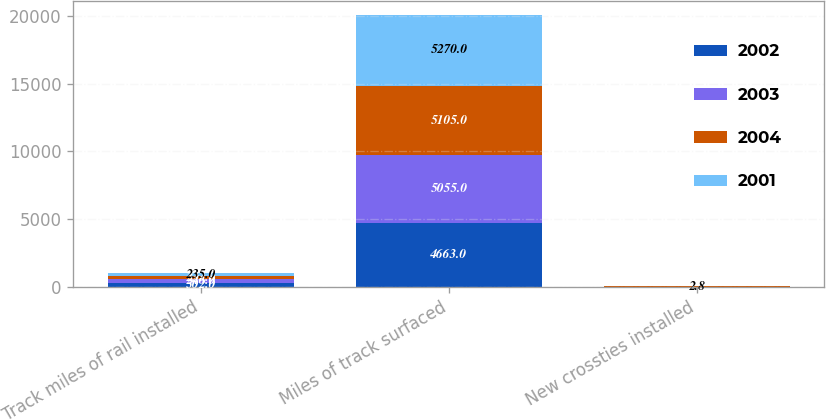Convert chart to OTSL. <chart><loc_0><loc_0><loc_500><loc_500><stacked_bar_chart><ecel><fcel>Track miles of rail installed<fcel>Miles of track surfaced<fcel>New crossties installed<nl><fcel>2002<fcel>302<fcel>4663<fcel>2.5<nl><fcel>2003<fcel>246<fcel>5055<fcel>2.5<nl><fcel>2004<fcel>233<fcel>5105<fcel>2.8<nl><fcel>2001<fcel>235<fcel>5270<fcel>2.8<nl></chart> 